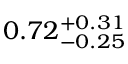<formula> <loc_0><loc_0><loc_500><loc_500>0 . 7 2 _ { - 0 . 2 5 } ^ { + 0 . 3 1 }</formula> 